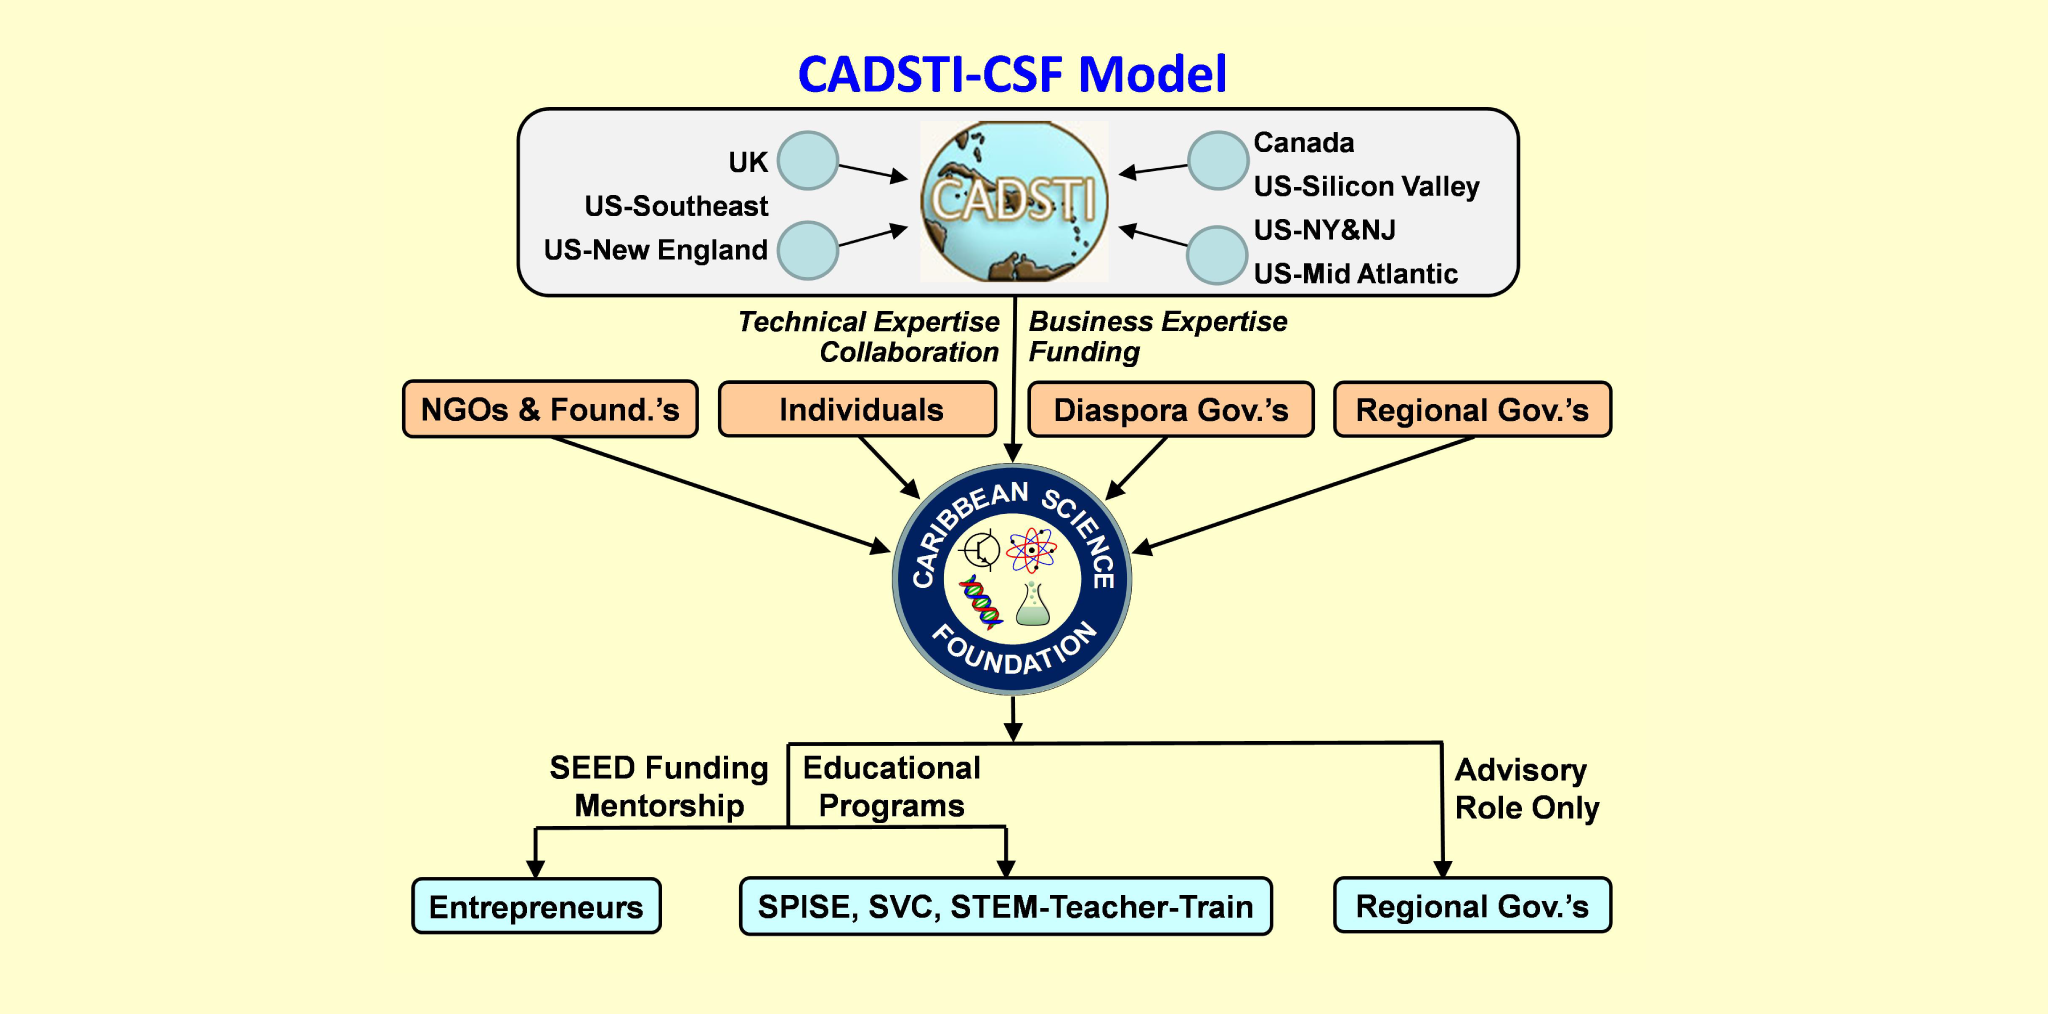If the Caribbean Science Foundation were to create an innovative tech startup accelerator powered by AI and machine learning, what key features would be most beneficial? An innovative tech startup accelerator powered by AI and machine learning, established by the Caribbean Science Foundation, would greatly benefit from the following key features: personalized mentorship matching, utilizing AI to pair startups with the most suitable mentors based on specific needs and goals; predictive analytics to identify high-potential startups and provide data-driven insights for strategic decisions; adaptive learning platforms offering customized training programs based on real-time performance metrics; and advanced networking tools to connect startups with potential investors, partners, and global markets. Such an accelerator would significantly enhance the growth and success rates of tech startups in the Caribbean. 